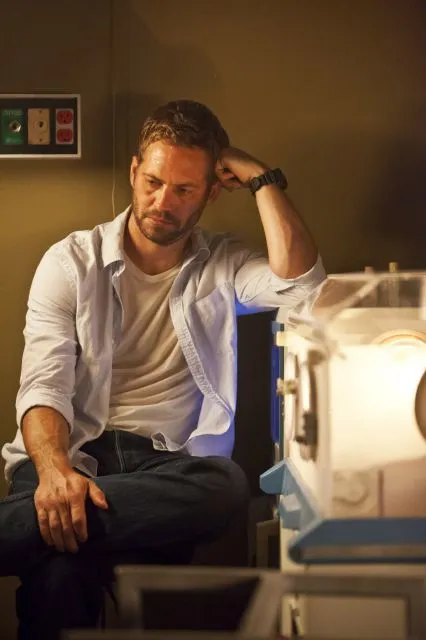What might the man be thinking about? The man could be contemplating a complex problem or a critical decision related to his work in the laboratory. Given the scientific setting, he might be reflecting on research data, formulating hypotheses, or considering the next steps in an experiment. What kind of experiment do you think he’s working on? Given the look of the laboratory and the specialized equipment to his right, it's possible he could be working on a high-tech research project, perhaps involving biomedical research or advanced engineering. The device could be used for experiments that require precise environmental conditions, such as incubating sharegpt4v/samples or conducting tests on new materials. 